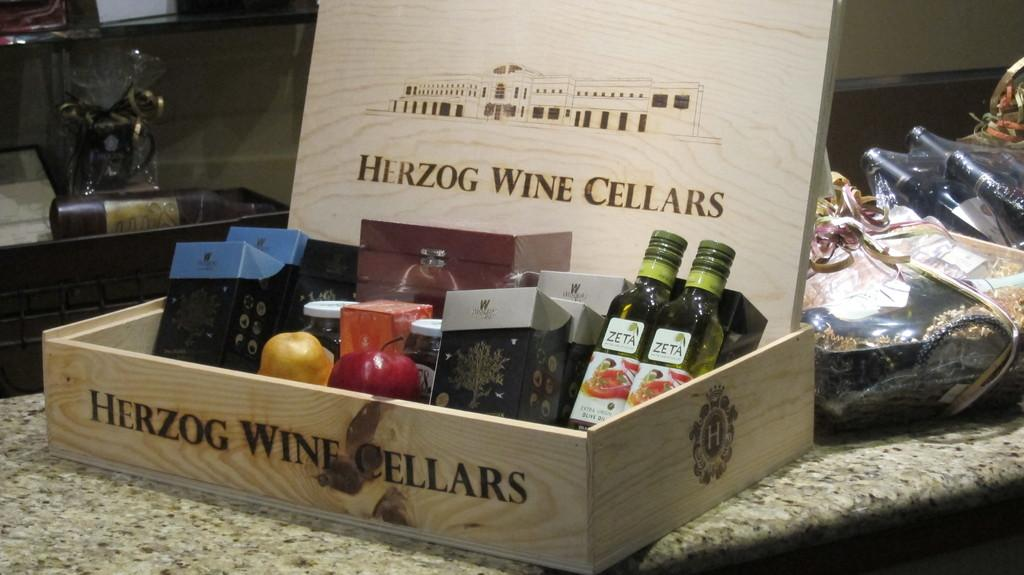<image>
Share a concise interpretation of the image provided. Nice wooden box of Herzon Wine and fruits 